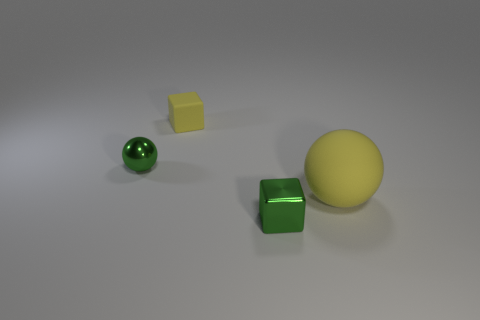Add 1 matte objects. How many objects exist? 5 Add 2 big rubber objects. How many big rubber objects exist? 3 Subtract 1 green blocks. How many objects are left? 3 Subtract all yellow spheres. Subtract all tiny rubber things. How many objects are left? 2 Add 3 large rubber objects. How many large rubber objects are left? 4 